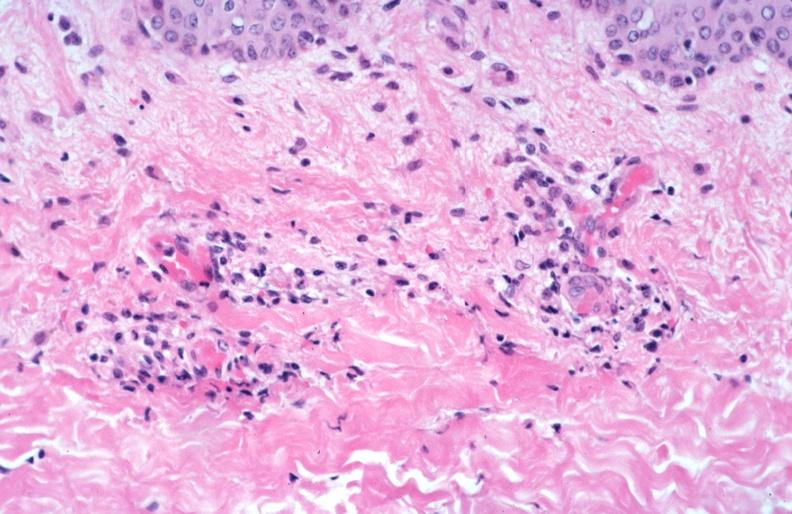s rocky mountain spotted fever, vasculitis?
Answer the question using a single word or phrase. Yes 